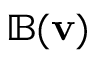Convert formula to latex. <formula><loc_0><loc_0><loc_500><loc_500>\mathbb { B } ( v )</formula> 